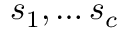<formula> <loc_0><loc_0><loc_500><loc_500>s _ { 1 } , \dots s _ { c }</formula> 